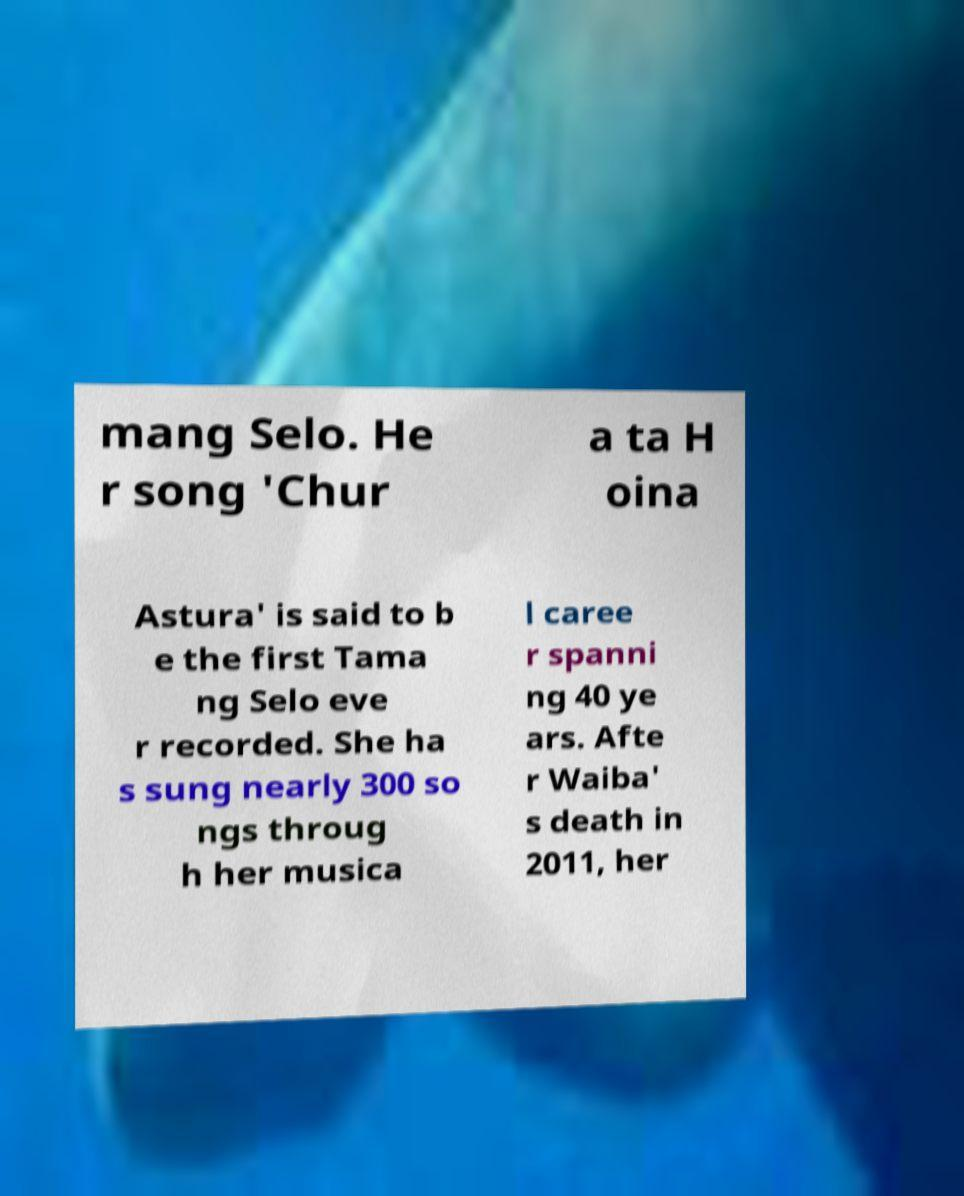Could you extract and type out the text from this image? mang Selo. He r song 'Chur a ta H oina Astura' is said to b e the first Tama ng Selo eve r recorded. She ha s sung nearly 300 so ngs throug h her musica l caree r spanni ng 40 ye ars. Afte r Waiba' s death in 2011, her 